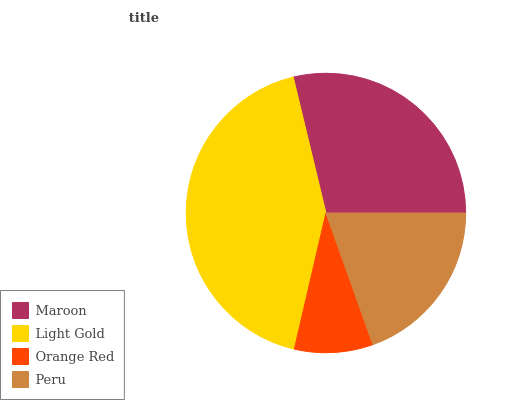Is Orange Red the minimum?
Answer yes or no. Yes. Is Light Gold the maximum?
Answer yes or no. Yes. Is Light Gold the minimum?
Answer yes or no. No. Is Orange Red the maximum?
Answer yes or no. No. Is Light Gold greater than Orange Red?
Answer yes or no. Yes. Is Orange Red less than Light Gold?
Answer yes or no. Yes. Is Orange Red greater than Light Gold?
Answer yes or no. No. Is Light Gold less than Orange Red?
Answer yes or no. No. Is Maroon the high median?
Answer yes or no. Yes. Is Peru the low median?
Answer yes or no. Yes. Is Peru the high median?
Answer yes or no. No. Is Orange Red the low median?
Answer yes or no. No. 